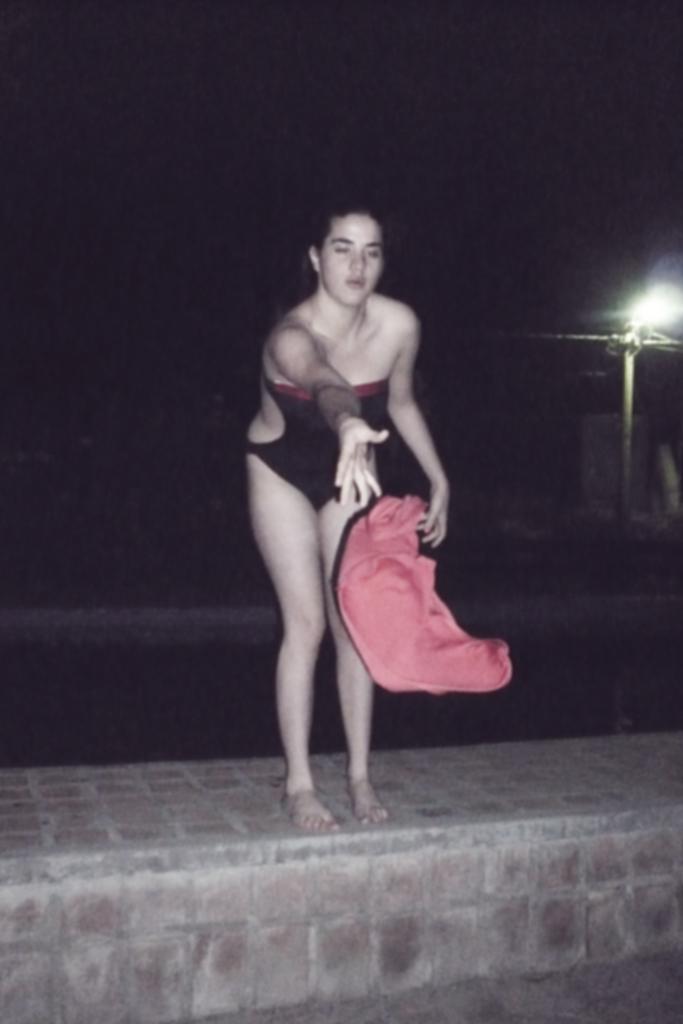In one or two sentences, can you explain what this image depicts? In this image we can see a woman in swimming dress, she is throwing one orange color cloth and she is standing on a brick wall. Behind her complete darkness is present. 